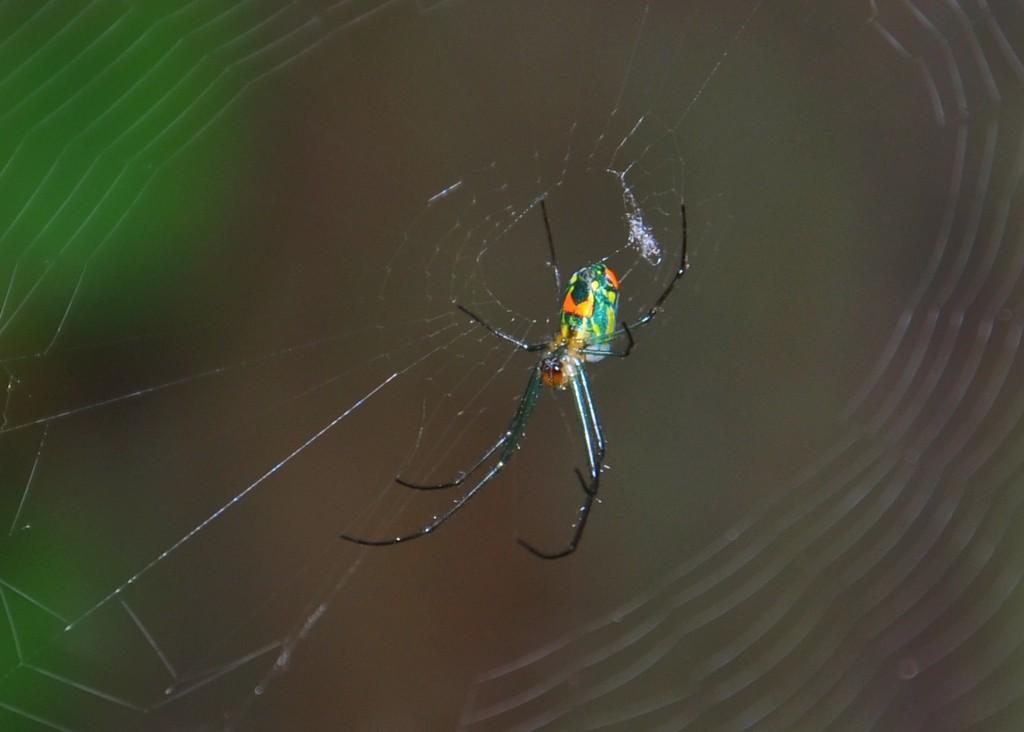Describe this image in one or two sentences. In this picture we can see a spider and blurry background. 